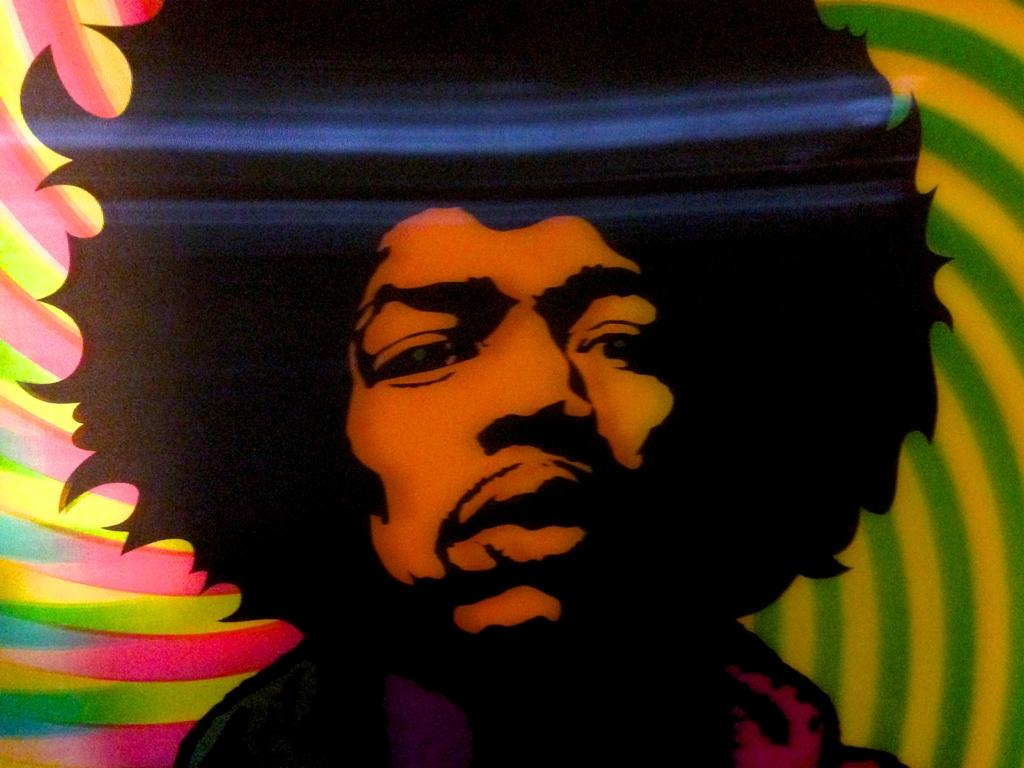Who is present in the image? There is a man in the image. What type of artwork is the image? The image is a sketch. What colors can be seen in the background of the image? There are different colors in the background of the image, including green, yellow, pink, and blue. What grade did the man receive in his class for this sketch? The image does not provide any information about a class or grade, as it is a standalone sketch. 